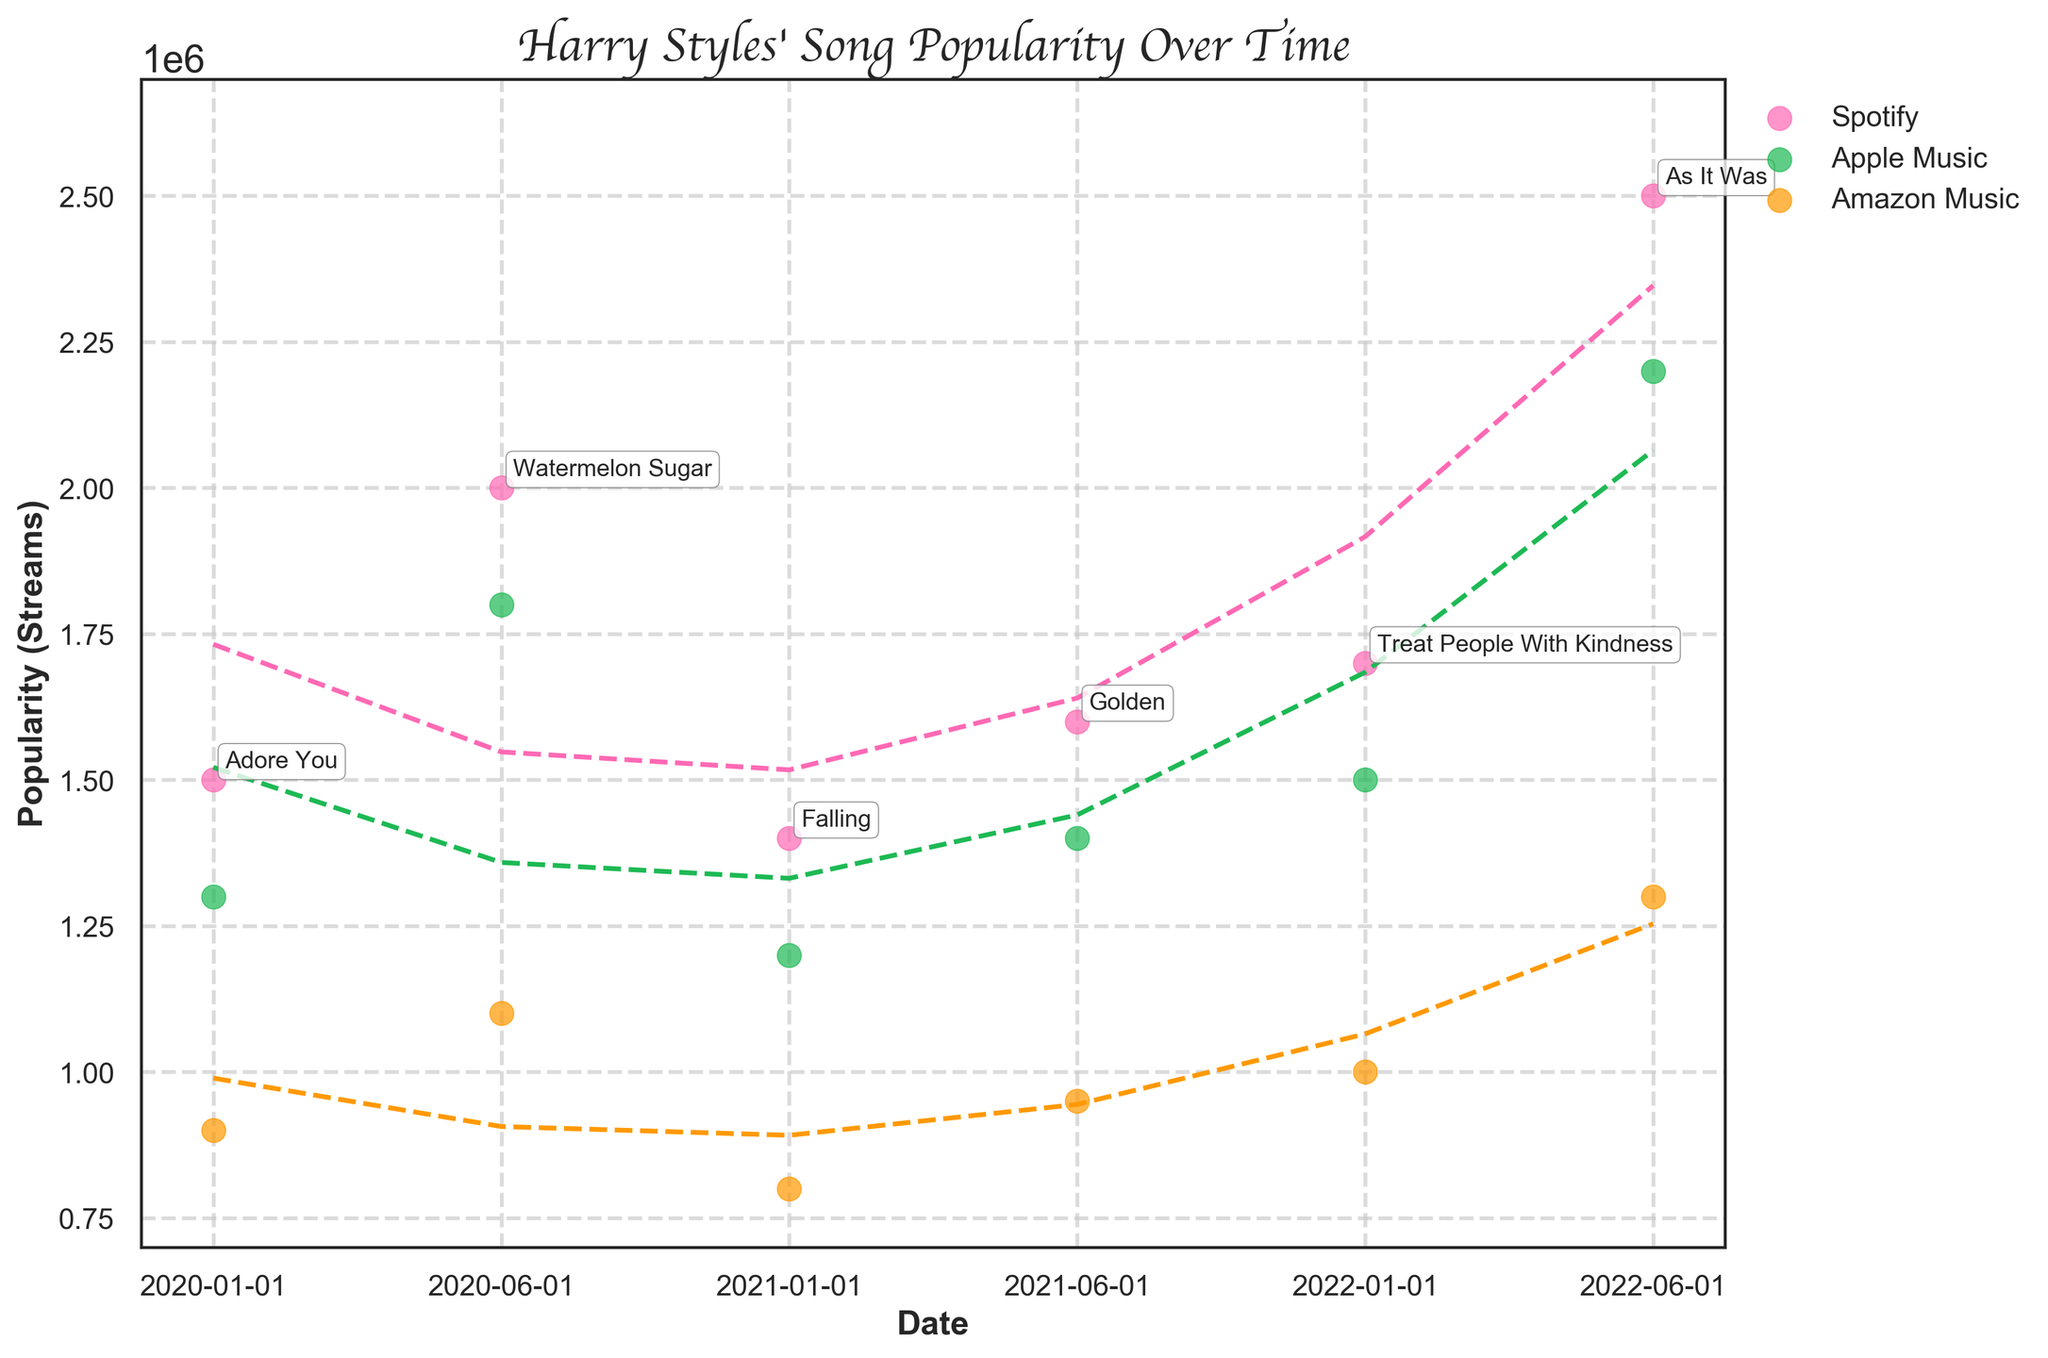What is the title of the plot? The title of the plot is written at the top of the figure and reads "Harry Styles' Song Popularity Over Time".
Answer: "Harry Styles' Song Popularity Over Time" What colors are used to represent the different streaming platforms? The colors used for the platforms are visible in the legend: Pink for one platform, green for another, and orange for the third.
Answer: Pink, Green, Orange Which song had the highest peak popularity and on which platform? By looking at the scatter points, the highest peak popularity can be identified where the point reaches the highest value on the y-axis. The color indicates the platform.
Answer: "As It Was" on Spotify What is the average peak popularity of "Watermelon Sugar" across all platforms? The popularity for "Watermelon Sugar" on Spotify, Apple Music, and Amazon Music are 2000000, 1800000, and 1100000 respectively. Calculate the average of these values by summing them and then dividing by 3.
Answer: (2000000 + 1800000 + 1100000) / 3 = 1633333.33 Which platform shows the smoothest increasing trend line over time? By examining the fitted polynomial trend lines for each platform, the platform with the most consistent (smoothest) upward slope over time can be identified.
Answer: Spotify Between "Golden" and "Treat People With Kindness," which song had more popularity on Apple Music? Locate the points for "Golden" and "Treat People With Kindness" on Apple Music (color-coded accordingly) to compare their popularity values.
Answer: "Treat People With Kindness" Is there any song whose popularity on Amazon Music is consistently the lowest compared to the other platforms? Compare the popularity values for each song across all platforms to see if there is one that consistently has the lowest values on Amazon Music.
Answer: Yes, "As It Was" Which date range shows the most significant growth in popularity for Harry Styles’ songs on Spotify? By looking at the trend lines, identify the period where the slope of the line representing Spotify is steepest, indicating the most significant growth.
Answer: Between January 2020 and June 2022 How does the popularity trend of "Adore You" compare across different platforms? Examine the scatter points and trend lines for "Adore You" (distinctively marked and annotated) on each platform to see the differences in popularity growth or decline.
Answer: "Adore You" is most popular on Spotify, followed by Apple Music, then Amazon Music How does the overall popularity trend for Amazon Music differ from Spotify? Compare the overall shape and direction of the trend lines for Amazon Music and Spotify. Note any differences in growth, decline, or consistency over time.
Answer: Amazon Music shows less growth and more fluctuations compared to Spotify 